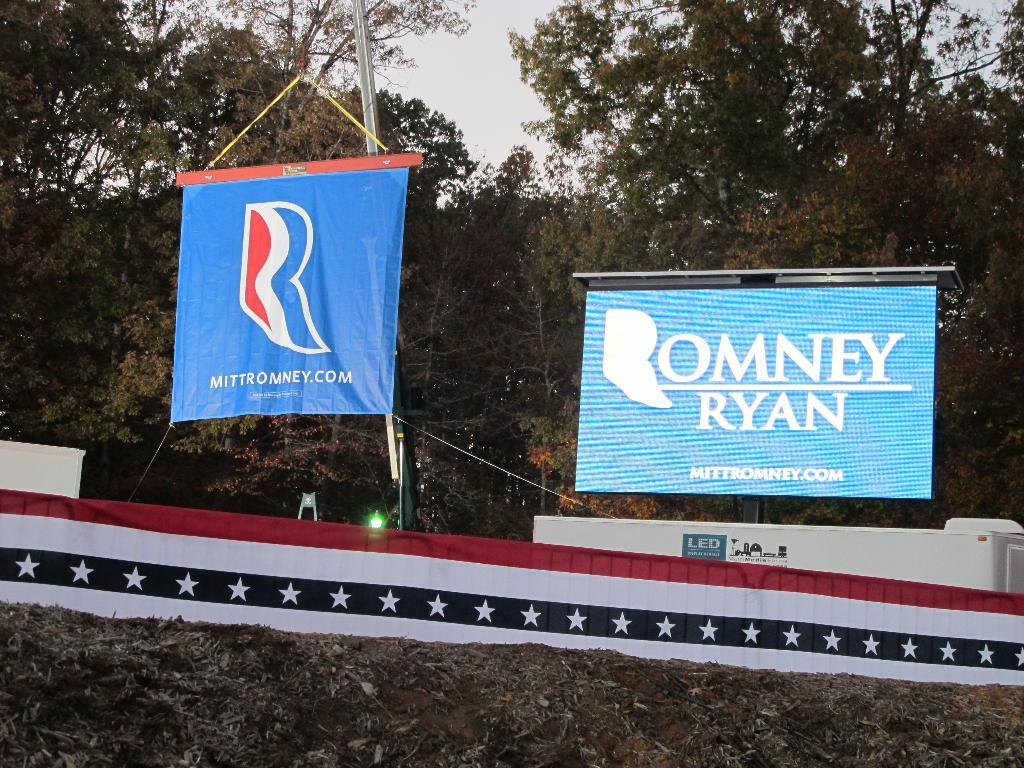<image>
Create a compact narrative representing the image presented. Political banners remind voters to remember Mitt Romney and Paul Ryan. 